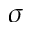<formula> <loc_0><loc_0><loc_500><loc_500>\sigma</formula> 